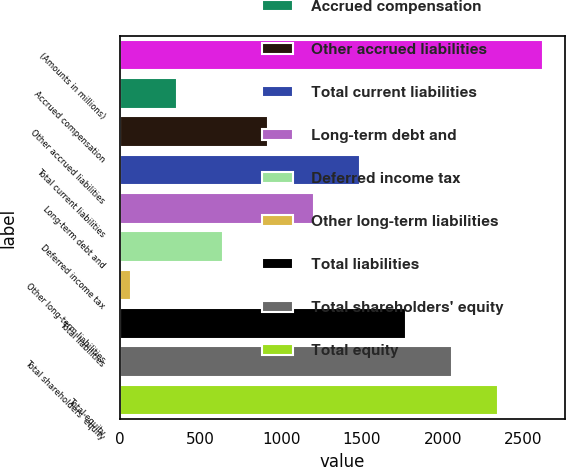Convert chart. <chart><loc_0><loc_0><loc_500><loc_500><bar_chart><fcel>(Amounts in millions)<fcel>Accrued compensation<fcel>Other accrued liabilities<fcel>Total current liabilities<fcel>Long-term debt and<fcel>Deferred income tax<fcel>Other long-term liabilities<fcel>Total liabilities<fcel>Total shareholders' equity<fcel>Total equity<nl><fcel>2623.15<fcel>353.95<fcel>921.25<fcel>1488.55<fcel>1204.9<fcel>637.6<fcel>70.3<fcel>1772.2<fcel>2055.85<fcel>2339.5<nl></chart> 